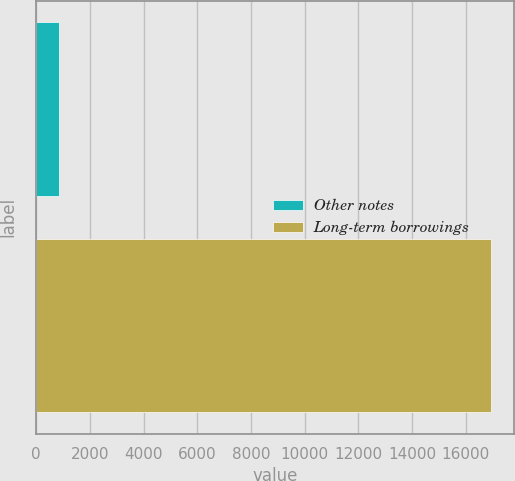<chart> <loc_0><loc_0><loc_500><loc_500><bar_chart><fcel>Other notes<fcel>Long-term borrowings<nl><fcel>853<fcel>16960<nl></chart> 